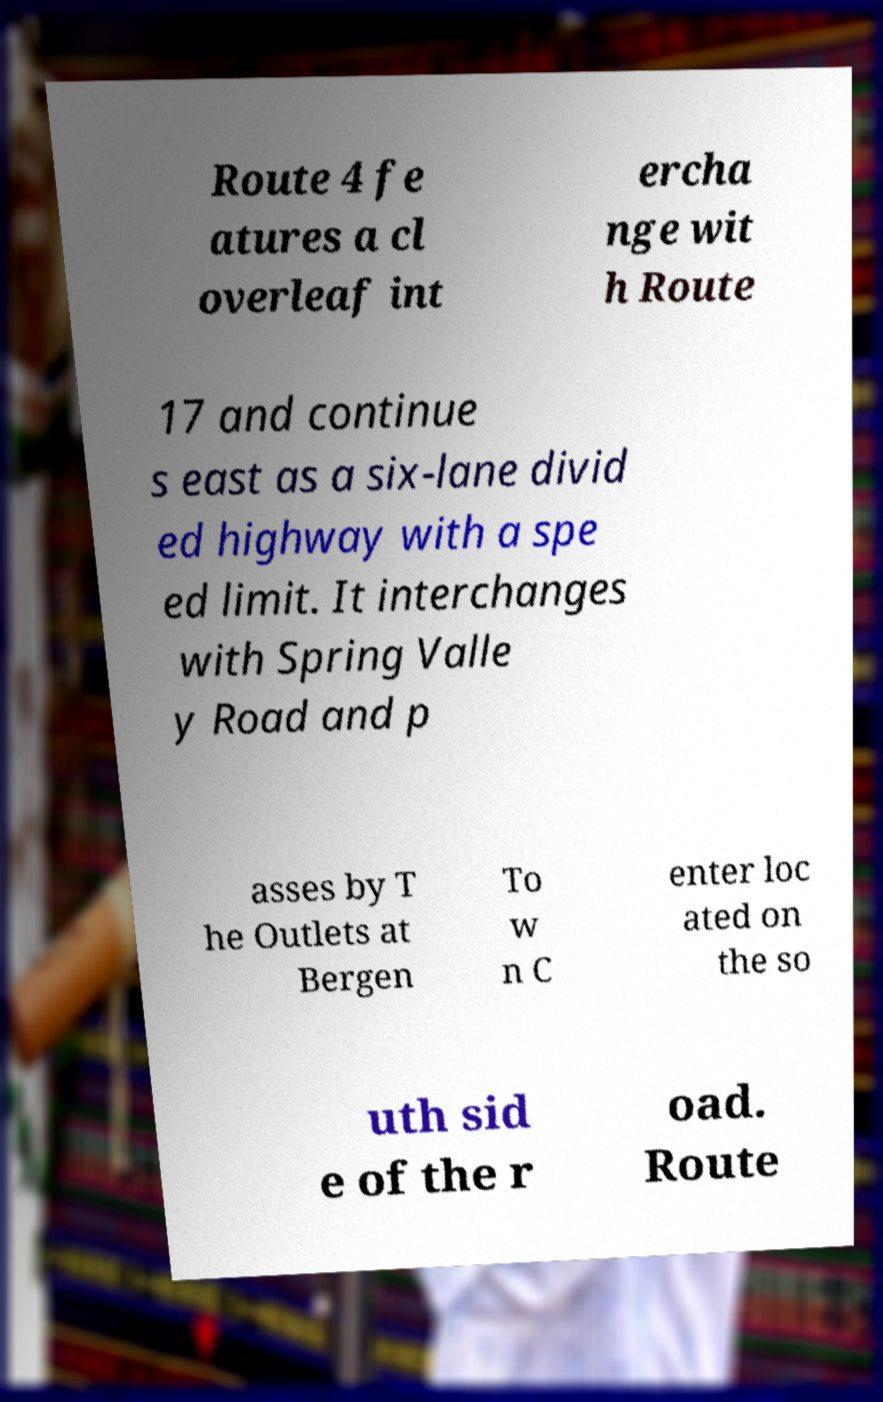For documentation purposes, I need the text within this image transcribed. Could you provide that? Route 4 fe atures a cl overleaf int ercha nge wit h Route 17 and continue s east as a six-lane divid ed highway with a spe ed limit. It interchanges with Spring Valle y Road and p asses by T he Outlets at Bergen To w n C enter loc ated on the so uth sid e of the r oad. Route 